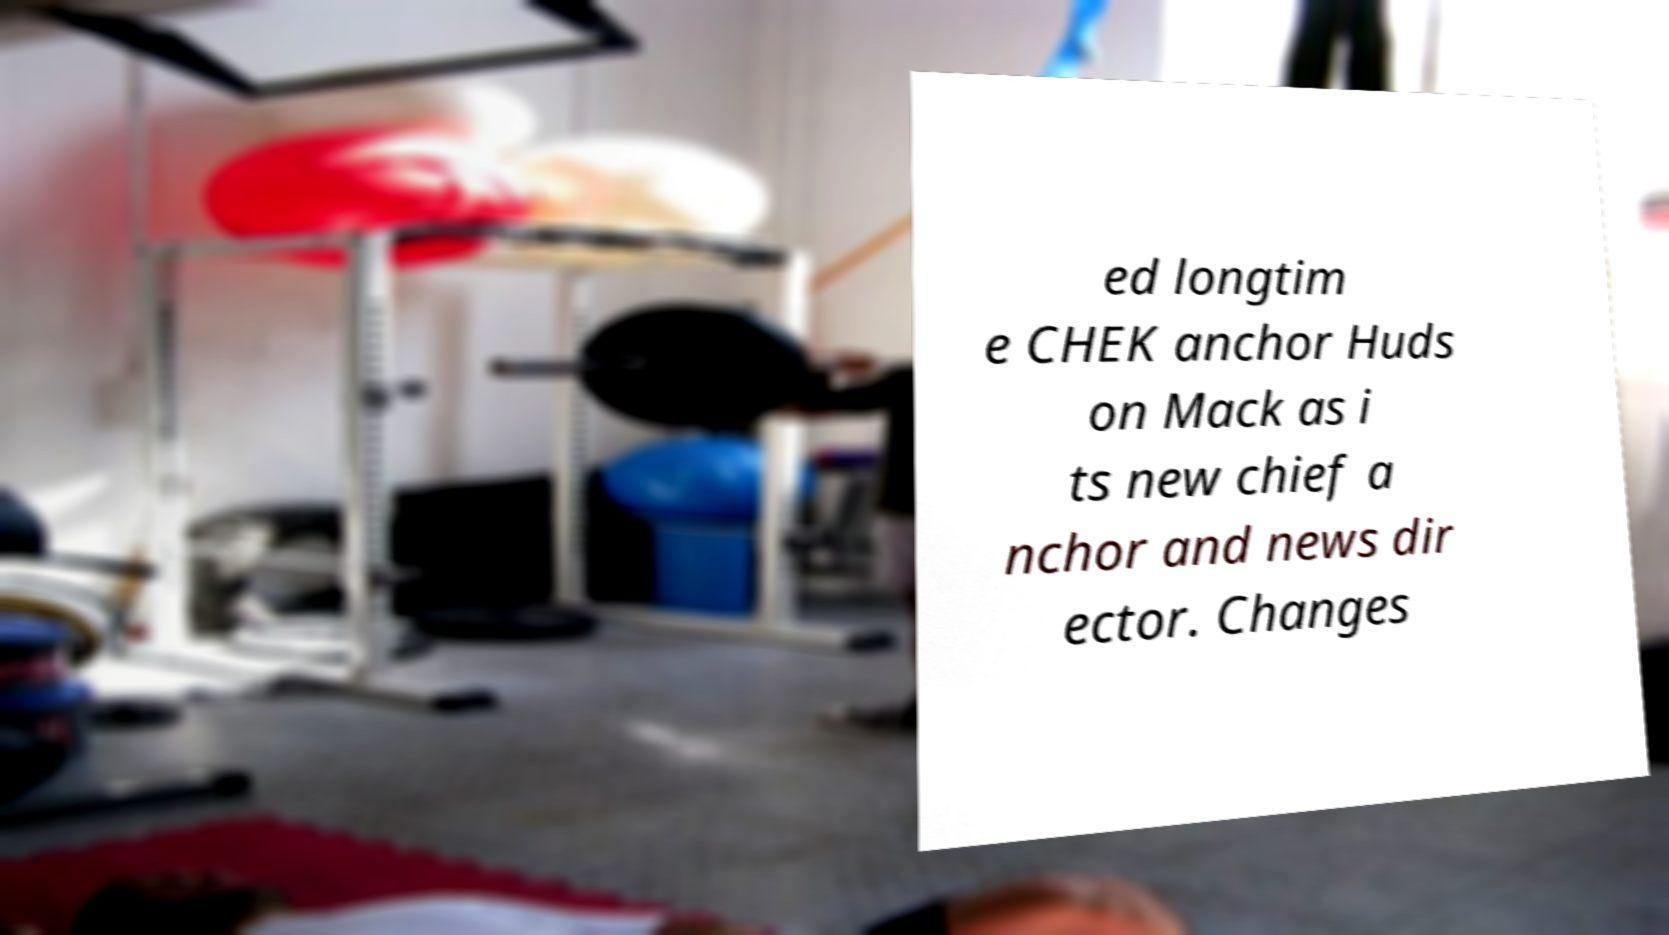Can you accurately transcribe the text from the provided image for me? ed longtim e CHEK anchor Huds on Mack as i ts new chief a nchor and news dir ector. Changes 